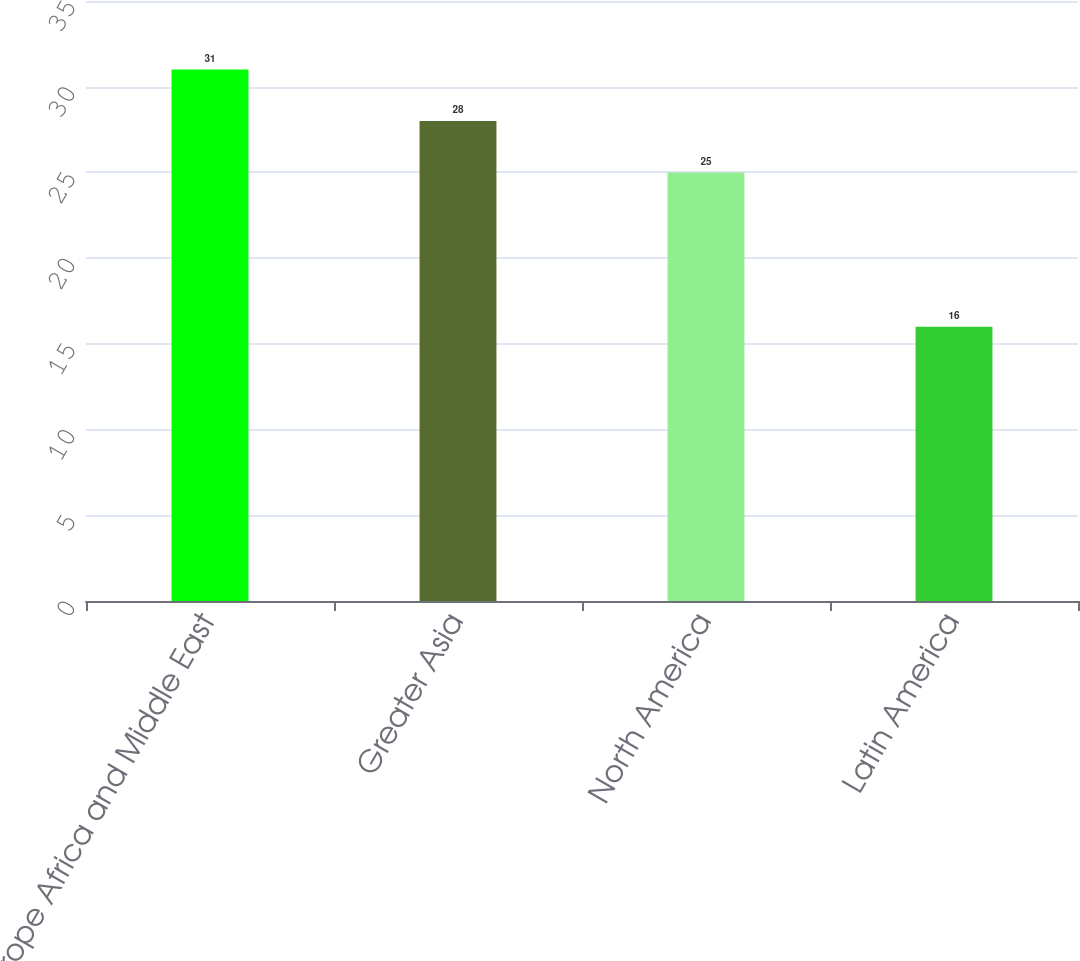<chart> <loc_0><loc_0><loc_500><loc_500><bar_chart><fcel>Europe Africa and Middle East<fcel>Greater Asia<fcel>North America<fcel>Latin America<nl><fcel>31<fcel>28<fcel>25<fcel>16<nl></chart> 